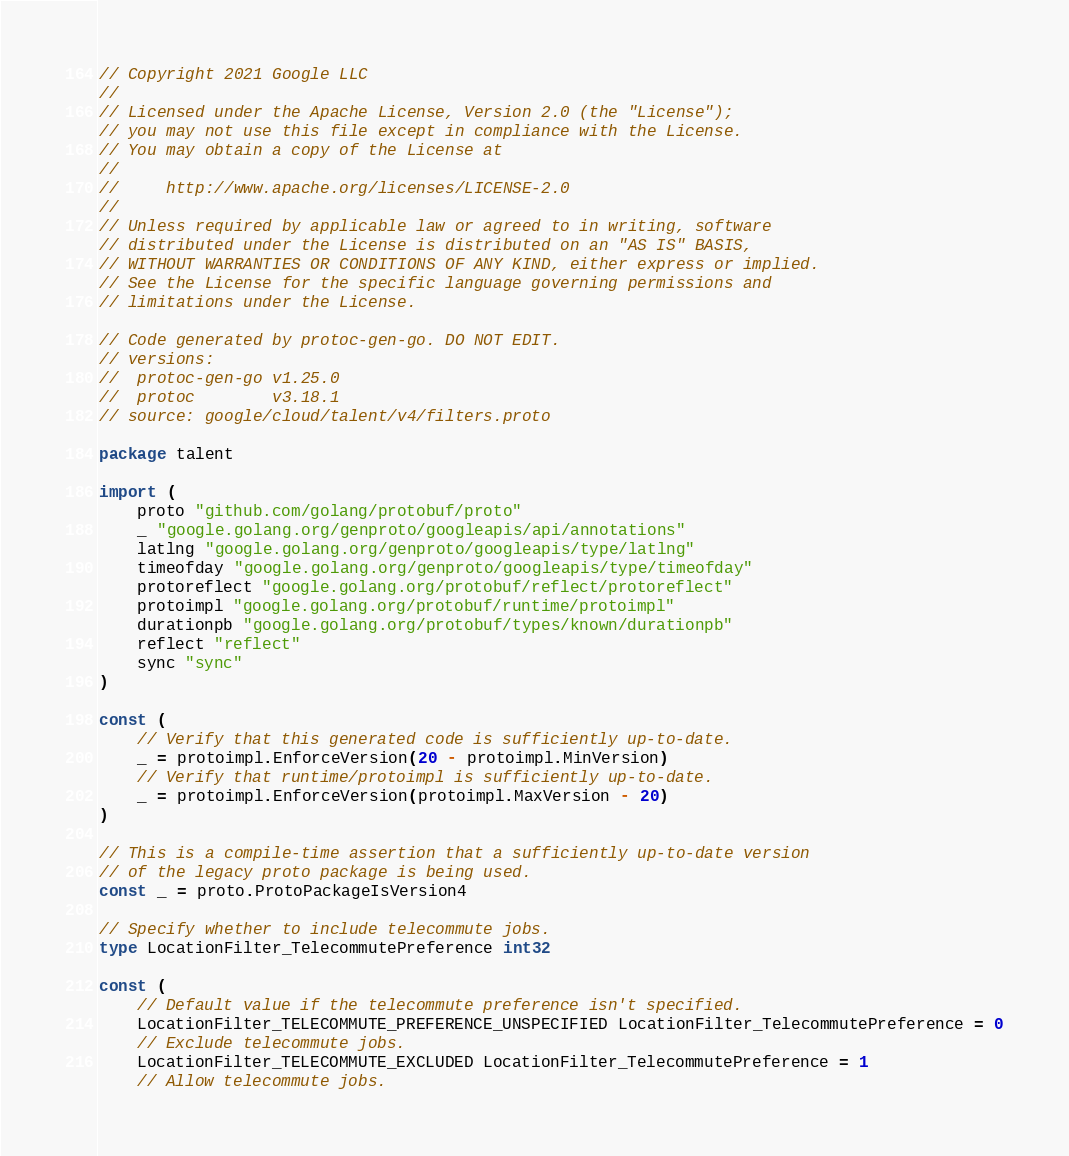<code> <loc_0><loc_0><loc_500><loc_500><_Go_>// Copyright 2021 Google LLC
//
// Licensed under the Apache License, Version 2.0 (the "License");
// you may not use this file except in compliance with the License.
// You may obtain a copy of the License at
//
//     http://www.apache.org/licenses/LICENSE-2.0
//
// Unless required by applicable law or agreed to in writing, software
// distributed under the License is distributed on an "AS IS" BASIS,
// WITHOUT WARRANTIES OR CONDITIONS OF ANY KIND, either express or implied.
// See the License for the specific language governing permissions and
// limitations under the License.

// Code generated by protoc-gen-go. DO NOT EDIT.
// versions:
// 	protoc-gen-go v1.25.0
// 	protoc        v3.18.1
// source: google/cloud/talent/v4/filters.proto

package talent

import (
	proto "github.com/golang/protobuf/proto"
	_ "google.golang.org/genproto/googleapis/api/annotations"
	latlng "google.golang.org/genproto/googleapis/type/latlng"
	timeofday "google.golang.org/genproto/googleapis/type/timeofday"
	protoreflect "google.golang.org/protobuf/reflect/protoreflect"
	protoimpl "google.golang.org/protobuf/runtime/protoimpl"
	durationpb "google.golang.org/protobuf/types/known/durationpb"
	reflect "reflect"
	sync "sync"
)

const (
	// Verify that this generated code is sufficiently up-to-date.
	_ = protoimpl.EnforceVersion(20 - protoimpl.MinVersion)
	// Verify that runtime/protoimpl is sufficiently up-to-date.
	_ = protoimpl.EnforceVersion(protoimpl.MaxVersion - 20)
)

// This is a compile-time assertion that a sufficiently up-to-date version
// of the legacy proto package is being used.
const _ = proto.ProtoPackageIsVersion4

// Specify whether to include telecommute jobs.
type LocationFilter_TelecommutePreference int32

const (
	// Default value if the telecommute preference isn't specified.
	LocationFilter_TELECOMMUTE_PREFERENCE_UNSPECIFIED LocationFilter_TelecommutePreference = 0
	// Exclude telecommute jobs.
	LocationFilter_TELECOMMUTE_EXCLUDED LocationFilter_TelecommutePreference = 1
	// Allow telecommute jobs.</code> 